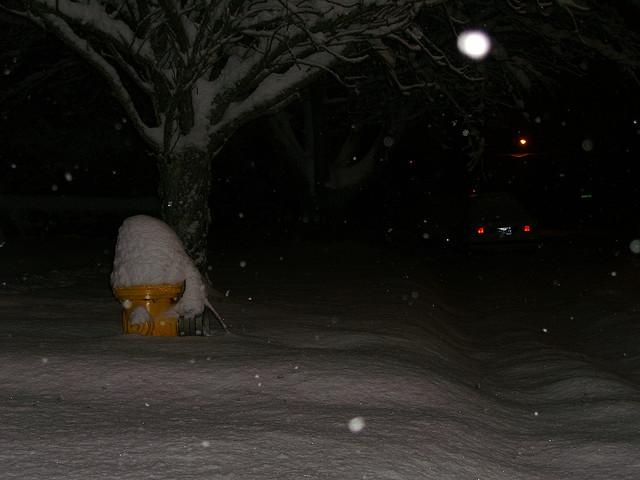What is covering the ground?
Short answer required. Snow. How many buckets are visible?
Be succinct. 1. What is bright in the background?
Answer briefly. Moon. Is it night time?
Keep it brief. Yes. Why is this view obscured?
Quick response, please. Snow. Is the image in black and white?
Short answer required. No. What is the white object?
Quick response, please. Snow. Where is the man?
Short answer required. Outside. What is the red lights?
Give a very brief answer. Car lights. What type of scene is this?
Quick response, please. Snowy. 